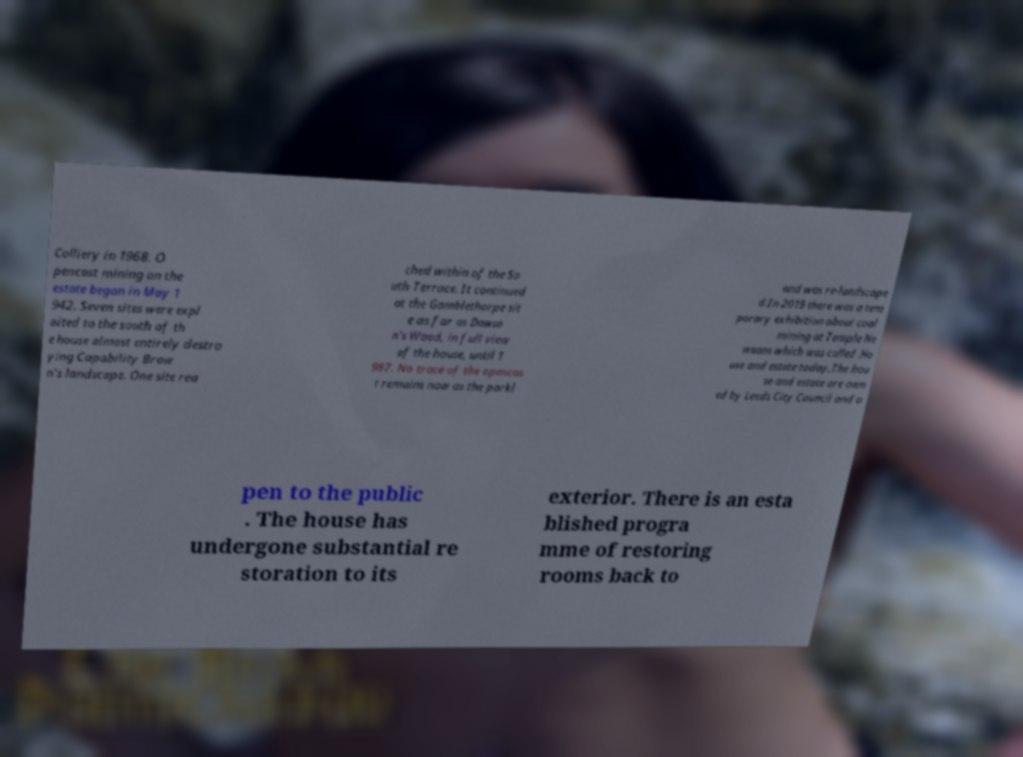There's text embedded in this image that I need extracted. Can you transcribe it verbatim? Colliery in 1968. O pencast mining on the estate began in May 1 942. Seven sites were expl oited to the south of th e house almost entirely destro ying Capability Brow n's landscape. One site rea ched within of the So uth Terrace. It continued at the Gamblethorpe sit e as far as Dawso n's Wood, in full view of the house, until 1 987. No trace of the opencas t remains now as the parkl and was re-landscape d.In 2019 there was a tem porary exhibition about coal mining at Temple Ne wsam which was called .Ho use and estate today.The hou se and estate are own ed by Leeds City Council and o pen to the public . The house has undergone substantial re storation to its exterior. There is an esta blished progra mme of restoring rooms back to 